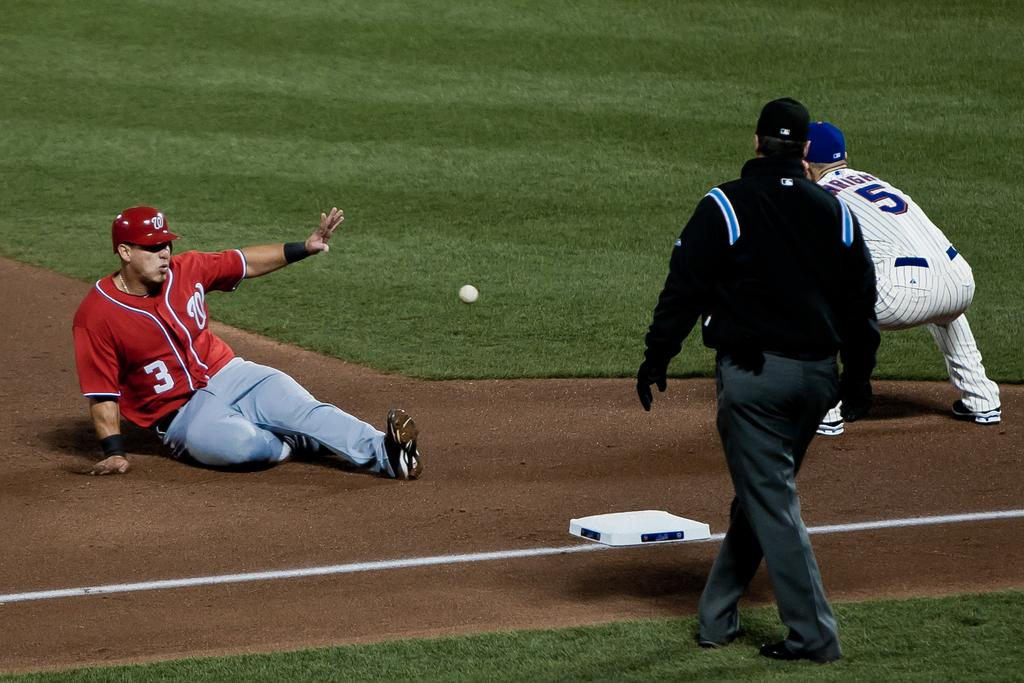<image>
Create a compact narrative representing the image presented. The baseball player sliding onto the base has W and 3 written on his jersey and two other players are with him on the field. 